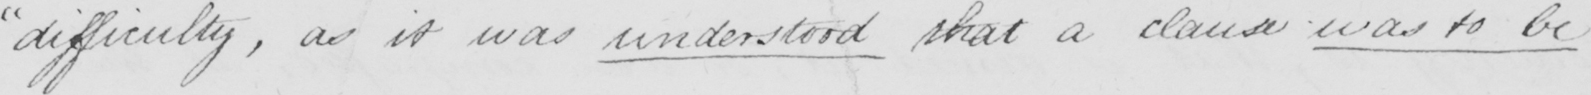Please provide the text content of this handwritten line. " difficulty , as it was understood that a clause was to be 